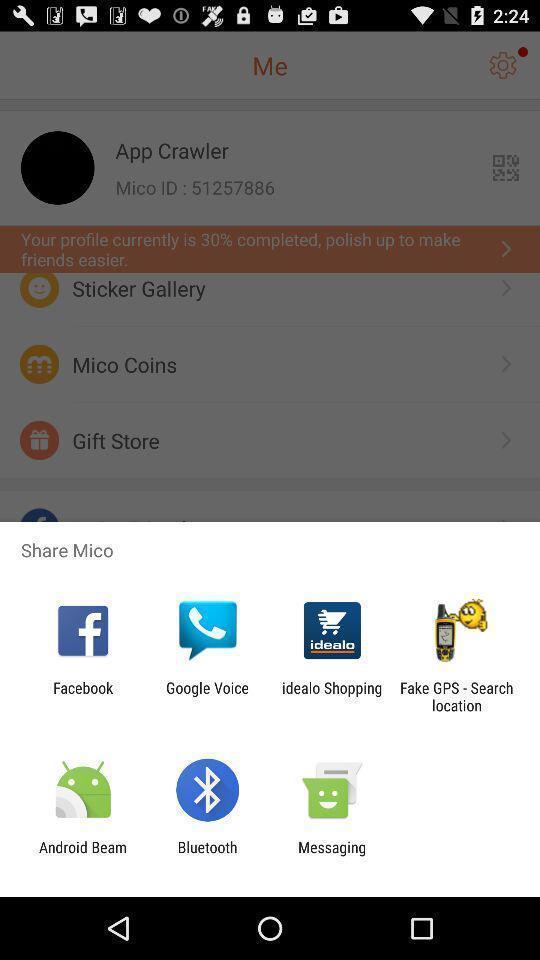Provide a textual representation of this image. Popup showing different apps to share. 